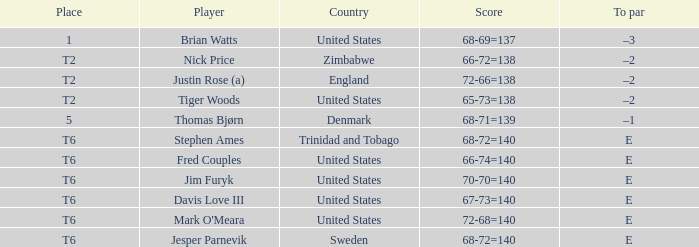In what place was Tiger Woods of the United States? T2. 